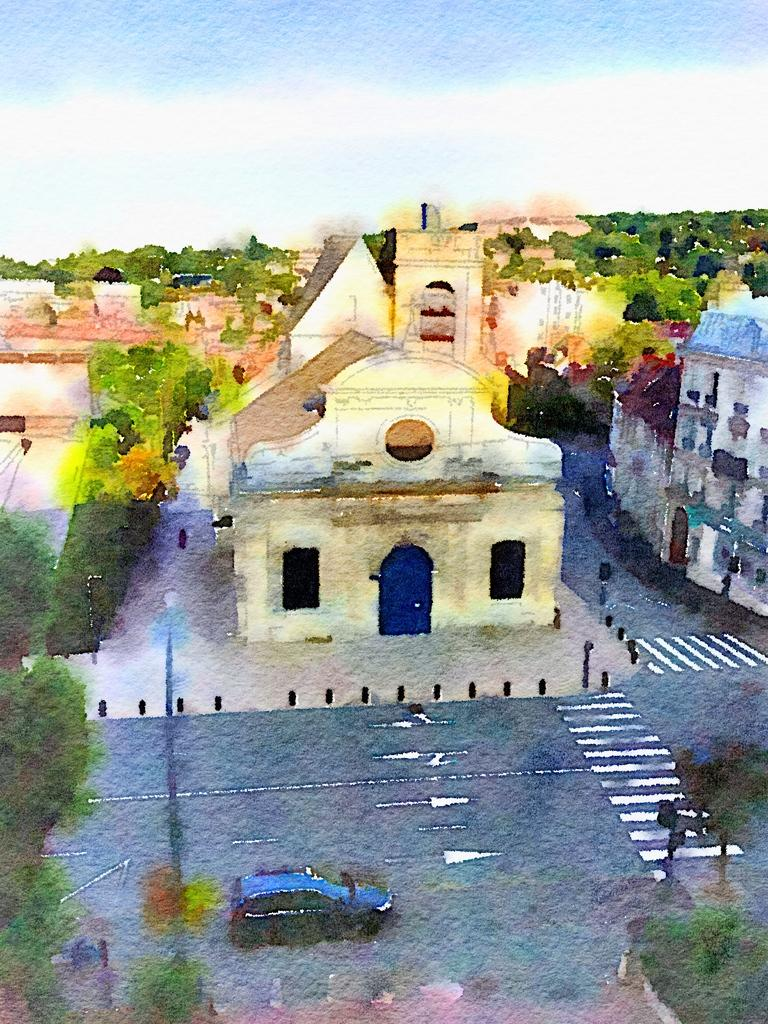What is the main subject of the image? The image contains a painting. What type of structures are depicted in the painting? There are houses in the painting. What other natural elements are present in the painting? There are trees in the painting. What mode of transportation can be seen in the painting? There is a car on the road in the painting. What type of lighting is present in the painting? There is a pole light in the painting. How would you describe the sky in the painting? The sky in the painting is blue and cloudy. What type of paper is being used to write a letter in the painting? There is no paper or letter-writing activity depicted in the painting; it features a scene with houses, trees, a car, a pole light, and a blue and cloudy sky. 